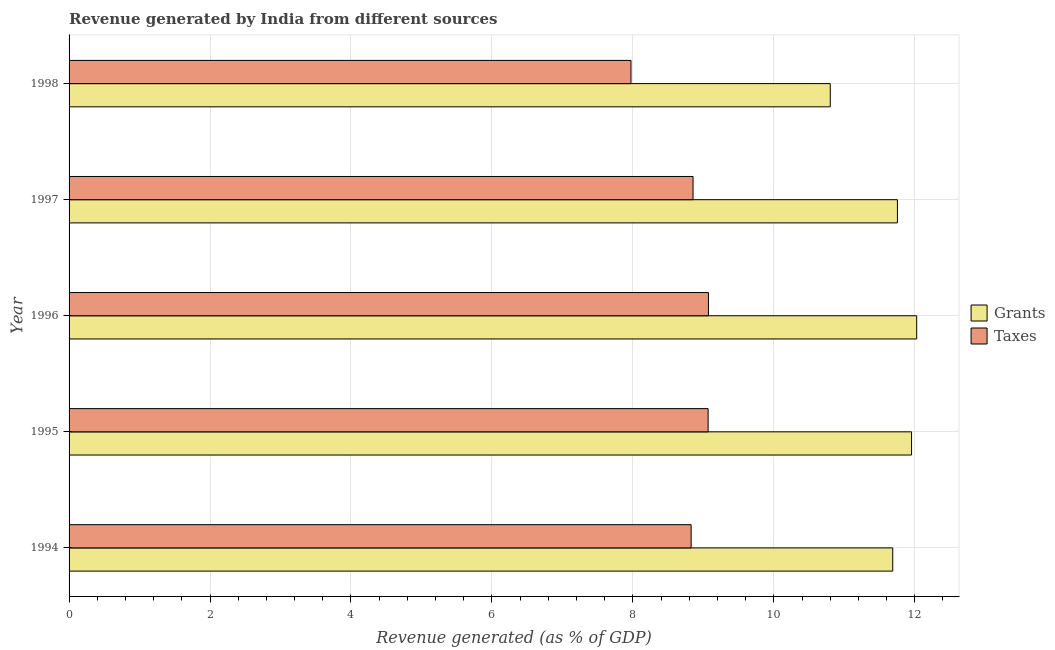How many groups of bars are there?
Your answer should be compact. 5. What is the revenue generated by grants in 1997?
Ensure brevity in your answer.  11.75. Across all years, what is the maximum revenue generated by taxes?
Your response must be concise. 9.07. Across all years, what is the minimum revenue generated by taxes?
Your response must be concise. 7.97. What is the total revenue generated by grants in the graph?
Your response must be concise. 58.22. What is the difference between the revenue generated by taxes in 1994 and that in 1997?
Make the answer very short. -0.03. What is the difference between the revenue generated by grants in 1995 and the revenue generated by taxes in 1997?
Offer a very short reply. 3.1. What is the average revenue generated by taxes per year?
Your answer should be compact. 8.76. In the year 1995, what is the difference between the revenue generated by grants and revenue generated by taxes?
Your answer should be very brief. 2.89. What is the ratio of the revenue generated by grants in 1997 to that in 1998?
Your response must be concise. 1.09. Is the difference between the revenue generated by taxes in 1996 and 1997 greater than the difference between the revenue generated by grants in 1996 and 1997?
Provide a short and direct response. No. What is the difference between the highest and the second highest revenue generated by grants?
Ensure brevity in your answer.  0.07. What does the 1st bar from the top in 1998 represents?
Offer a very short reply. Taxes. What does the 2nd bar from the bottom in 1998 represents?
Give a very brief answer. Taxes. How many bars are there?
Provide a short and direct response. 10. What is the difference between two consecutive major ticks on the X-axis?
Ensure brevity in your answer.  2. How are the legend labels stacked?
Ensure brevity in your answer.  Vertical. What is the title of the graph?
Make the answer very short. Revenue generated by India from different sources. What is the label or title of the X-axis?
Your response must be concise. Revenue generated (as % of GDP). What is the label or title of the Y-axis?
Make the answer very short. Year. What is the Revenue generated (as % of GDP) of Grants in 1994?
Provide a short and direct response. 11.69. What is the Revenue generated (as % of GDP) in Taxes in 1994?
Keep it short and to the point. 8.83. What is the Revenue generated (as % of GDP) in Grants in 1995?
Offer a very short reply. 11.95. What is the Revenue generated (as % of GDP) of Taxes in 1995?
Give a very brief answer. 9.07. What is the Revenue generated (as % of GDP) in Grants in 1996?
Keep it short and to the point. 12.03. What is the Revenue generated (as % of GDP) of Taxes in 1996?
Offer a terse response. 9.07. What is the Revenue generated (as % of GDP) in Grants in 1997?
Offer a very short reply. 11.75. What is the Revenue generated (as % of GDP) of Taxes in 1997?
Give a very brief answer. 8.85. What is the Revenue generated (as % of GDP) in Grants in 1998?
Your answer should be very brief. 10.8. What is the Revenue generated (as % of GDP) in Taxes in 1998?
Your answer should be very brief. 7.97. Across all years, what is the maximum Revenue generated (as % of GDP) of Grants?
Offer a terse response. 12.03. Across all years, what is the maximum Revenue generated (as % of GDP) of Taxes?
Offer a terse response. 9.07. Across all years, what is the minimum Revenue generated (as % of GDP) in Grants?
Ensure brevity in your answer.  10.8. Across all years, what is the minimum Revenue generated (as % of GDP) in Taxes?
Provide a short and direct response. 7.97. What is the total Revenue generated (as % of GDP) of Grants in the graph?
Your response must be concise. 58.22. What is the total Revenue generated (as % of GDP) of Taxes in the graph?
Your response must be concise. 43.79. What is the difference between the Revenue generated (as % of GDP) of Grants in 1994 and that in 1995?
Provide a short and direct response. -0.27. What is the difference between the Revenue generated (as % of GDP) of Taxes in 1994 and that in 1995?
Give a very brief answer. -0.24. What is the difference between the Revenue generated (as % of GDP) of Grants in 1994 and that in 1996?
Make the answer very short. -0.34. What is the difference between the Revenue generated (as % of GDP) in Taxes in 1994 and that in 1996?
Offer a very short reply. -0.25. What is the difference between the Revenue generated (as % of GDP) of Grants in 1994 and that in 1997?
Keep it short and to the point. -0.07. What is the difference between the Revenue generated (as % of GDP) of Taxes in 1994 and that in 1997?
Offer a very short reply. -0.03. What is the difference between the Revenue generated (as % of GDP) in Grants in 1994 and that in 1998?
Provide a succinct answer. 0.89. What is the difference between the Revenue generated (as % of GDP) of Taxes in 1994 and that in 1998?
Give a very brief answer. 0.85. What is the difference between the Revenue generated (as % of GDP) of Grants in 1995 and that in 1996?
Your response must be concise. -0.07. What is the difference between the Revenue generated (as % of GDP) in Taxes in 1995 and that in 1996?
Keep it short and to the point. -0. What is the difference between the Revenue generated (as % of GDP) in Grants in 1995 and that in 1997?
Make the answer very short. 0.2. What is the difference between the Revenue generated (as % of GDP) of Taxes in 1995 and that in 1997?
Your answer should be compact. 0.21. What is the difference between the Revenue generated (as % of GDP) of Grants in 1995 and that in 1998?
Your answer should be very brief. 1.15. What is the difference between the Revenue generated (as % of GDP) in Taxes in 1995 and that in 1998?
Ensure brevity in your answer.  1.09. What is the difference between the Revenue generated (as % of GDP) of Grants in 1996 and that in 1997?
Make the answer very short. 0.27. What is the difference between the Revenue generated (as % of GDP) in Taxes in 1996 and that in 1997?
Provide a short and direct response. 0.22. What is the difference between the Revenue generated (as % of GDP) of Grants in 1996 and that in 1998?
Ensure brevity in your answer.  1.23. What is the difference between the Revenue generated (as % of GDP) in Taxes in 1996 and that in 1998?
Offer a terse response. 1.1. What is the difference between the Revenue generated (as % of GDP) of Grants in 1997 and that in 1998?
Offer a terse response. 0.95. What is the difference between the Revenue generated (as % of GDP) in Taxes in 1997 and that in 1998?
Keep it short and to the point. 0.88. What is the difference between the Revenue generated (as % of GDP) in Grants in 1994 and the Revenue generated (as % of GDP) in Taxes in 1995?
Your response must be concise. 2.62. What is the difference between the Revenue generated (as % of GDP) of Grants in 1994 and the Revenue generated (as % of GDP) of Taxes in 1996?
Your answer should be very brief. 2.62. What is the difference between the Revenue generated (as % of GDP) of Grants in 1994 and the Revenue generated (as % of GDP) of Taxes in 1997?
Offer a terse response. 2.83. What is the difference between the Revenue generated (as % of GDP) in Grants in 1994 and the Revenue generated (as % of GDP) in Taxes in 1998?
Offer a terse response. 3.71. What is the difference between the Revenue generated (as % of GDP) of Grants in 1995 and the Revenue generated (as % of GDP) of Taxes in 1996?
Make the answer very short. 2.88. What is the difference between the Revenue generated (as % of GDP) in Grants in 1995 and the Revenue generated (as % of GDP) in Taxes in 1997?
Make the answer very short. 3.1. What is the difference between the Revenue generated (as % of GDP) in Grants in 1995 and the Revenue generated (as % of GDP) in Taxes in 1998?
Keep it short and to the point. 3.98. What is the difference between the Revenue generated (as % of GDP) in Grants in 1996 and the Revenue generated (as % of GDP) in Taxes in 1997?
Your answer should be compact. 3.17. What is the difference between the Revenue generated (as % of GDP) in Grants in 1996 and the Revenue generated (as % of GDP) in Taxes in 1998?
Offer a very short reply. 4.05. What is the difference between the Revenue generated (as % of GDP) of Grants in 1997 and the Revenue generated (as % of GDP) of Taxes in 1998?
Offer a very short reply. 3.78. What is the average Revenue generated (as % of GDP) of Grants per year?
Make the answer very short. 11.64. What is the average Revenue generated (as % of GDP) in Taxes per year?
Your answer should be compact. 8.76. In the year 1994, what is the difference between the Revenue generated (as % of GDP) in Grants and Revenue generated (as % of GDP) in Taxes?
Ensure brevity in your answer.  2.86. In the year 1995, what is the difference between the Revenue generated (as % of GDP) in Grants and Revenue generated (as % of GDP) in Taxes?
Offer a terse response. 2.89. In the year 1996, what is the difference between the Revenue generated (as % of GDP) of Grants and Revenue generated (as % of GDP) of Taxes?
Provide a succinct answer. 2.96. In the year 1997, what is the difference between the Revenue generated (as % of GDP) in Grants and Revenue generated (as % of GDP) in Taxes?
Provide a short and direct response. 2.9. In the year 1998, what is the difference between the Revenue generated (as % of GDP) of Grants and Revenue generated (as % of GDP) of Taxes?
Your response must be concise. 2.83. What is the ratio of the Revenue generated (as % of GDP) of Grants in 1994 to that in 1995?
Your answer should be very brief. 0.98. What is the ratio of the Revenue generated (as % of GDP) of Taxes in 1994 to that in 1995?
Your answer should be very brief. 0.97. What is the ratio of the Revenue generated (as % of GDP) of Grants in 1994 to that in 1996?
Give a very brief answer. 0.97. What is the ratio of the Revenue generated (as % of GDP) of Grants in 1994 to that in 1998?
Make the answer very short. 1.08. What is the ratio of the Revenue generated (as % of GDP) of Taxes in 1994 to that in 1998?
Provide a short and direct response. 1.11. What is the ratio of the Revenue generated (as % of GDP) of Grants in 1995 to that in 1996?
Provide a short and direct response. 0.99. What is the ratio of the Revenue generated (as % of GDP) in Taxes in 1995 to that in 1996?
Your answer should be compact. 1. What is the ratio of the Revenue generated (as % of GDP) in Grants in 1995 to that in 1997?
Ensure brevity in your answer.  1.02. What is the ratio of the Revenue generated (as % of GDP) of Taxes in 1995 to that in 1997?
Provide a short and direct response. 1.02. What is the ratio of the Revenue generated (as % of GDP) of Grants in 1995 to that in 1998?
Your response must be concise. 1.11. What is the ratio of the Revenue generated (as % of GDP) in Taxes in 1995 to that in 1998?
Keep it short and to the point. 1.14. What is the ratio of the Revenue generated (as % of GDP) in Grants in 1996 to that in 1997?
Your answer should be compact. 1.02. What is the ratio of the Revenue generated (as % of GDP) in Taxes in 1996 to that in 1997?
Ensure brevity in your answer.  1.02. What is the ratio of the Revenue generated (as % of GDP) of Grants in 1996 to that in 1998?
Your answer should be compact. 1.11. What is the ratio of the Revenue generated (as % of GDP) of Taxes in 1996 to that in 1998?
Make the answer very short. 1.14. What is the ratio of the Revenue generated (as % of GDP) of Grants in 1997 to that in 1998?
Your answer should be very brief. 1.09. What is the ratio of the Revenue generated (as % of GDP) in Taxes in 1997 to that in 1998?
Keep it short and to the point. 1.11. What is the difference between the highest and the second highest Revenue generated (as % of GDP) of Grants?
Ensure brevity in your answer.  0.07. What is the difference between the highest and the second highest Revenue generated (as % of GDP) in Taxes?
Offer a very short reply. 0. What is the difference between the highest and the lowest Revenue generated (as % of GDP) in Grants?
Give a very brief answer. 1.23. What is the difference between the highest and the lowest Revenue generated (as % of GDP) in Taxes?
Offer a terse response. 1.1. 